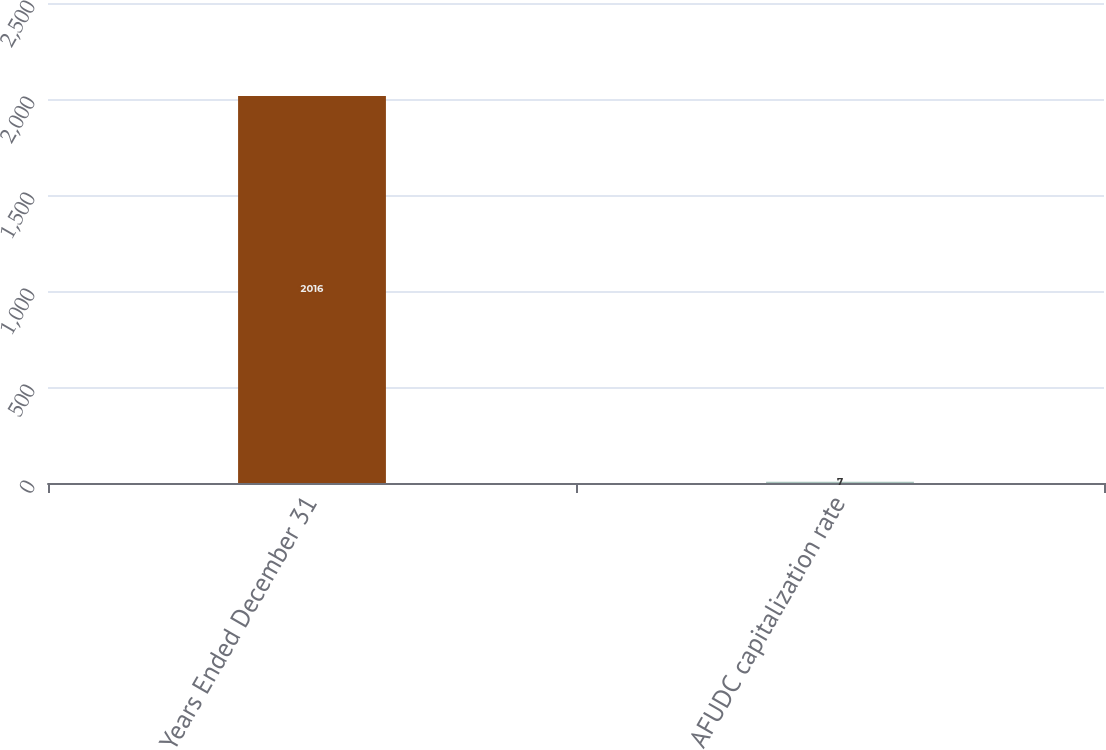Convert chart to OTSL. <chart><loc_0><loc_0><loc_500><loc_500><bar_chart><fcel>Years Ended December 31<fcel>AFUDC capitalization rate<nl><fcel>2016<fcel>7<nl></chart> 